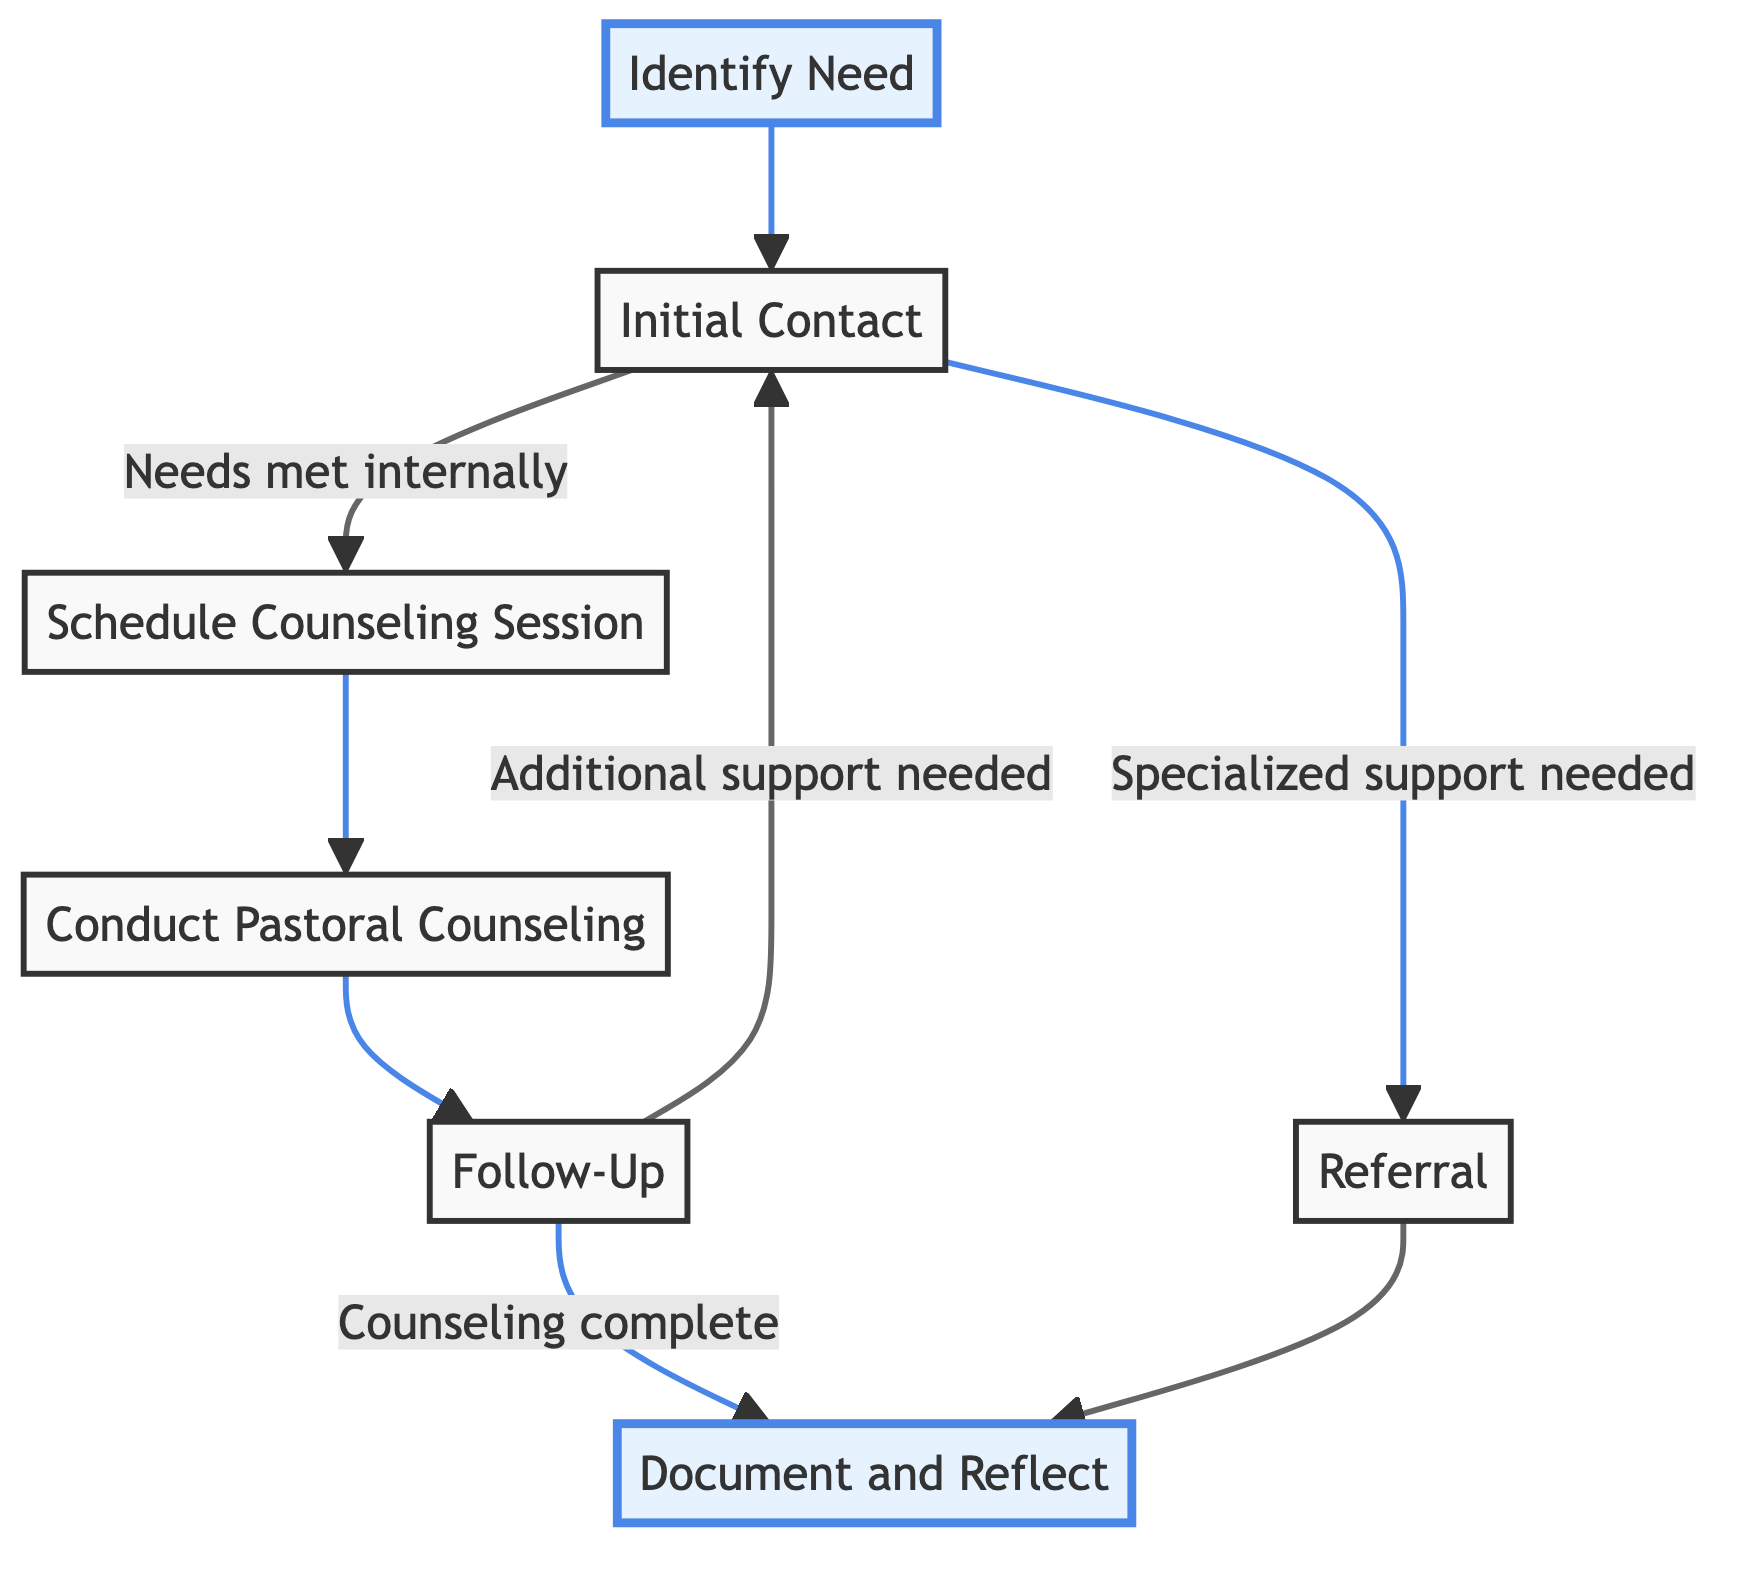What is the first step in the process? The first step in the process is "Identify Need," which is represented as the starting node in the diagram. The next node follows from this step.
Answer: Identify Need How many nodes are in the diagram? Counting all the distinct steps outlined in the diagram, there are seven nodes total, each representing a specific part of the counseling process.
Answer: 7 What happens after "Initial Contact"? Following "Initial Contact," the process can either lead to "Schedule Counseling Session" or "Referral," as indicated by the branching paths from this node.
Answer: Schedule Counseling Session or Referral Which step involves ongoing support? The step labeled "Follow-Up" provides for ongoing support, as it discusses planning for follow-up sessions or assessing progress after counseling is conducted.
Answer: Follow-Up If a referral is made, what is the next step? After making a referral, the next step is "Document and Reflect," which is the concluding part of this branch of the process according to the diagram.
Answer: Document and Reflect What are the two outcomes of the "Follow-Up" step? The two possible outcomes of the "Follow-Up" step are returning to "Initial Contact" for additional support or proceeding to "Document and Reflect" if counseling is complete, as shown in the diagram.
Answer: Initial Contact or Document and Reflect How is confidentiality addressed in the process? Confidentiality is addressed in the "Document and Reflect" step, where it is emphasized to document the session while ensuring confidentiality is maintained.
Answer: Document and Reflect Which step directly follows "Conduct Pastoral Counseling"? The step that directly follows "Conduct Pastoral Counseling" is "Follow-Up," indicating the next action taken after the counseling session.
Answer: Follow-Up What indicates the need for specialized support? The decision to refer an individual to a specialized mental health professional indicates the need for specialized support, as detailed in the "Referral" node.
Answer: Referral 